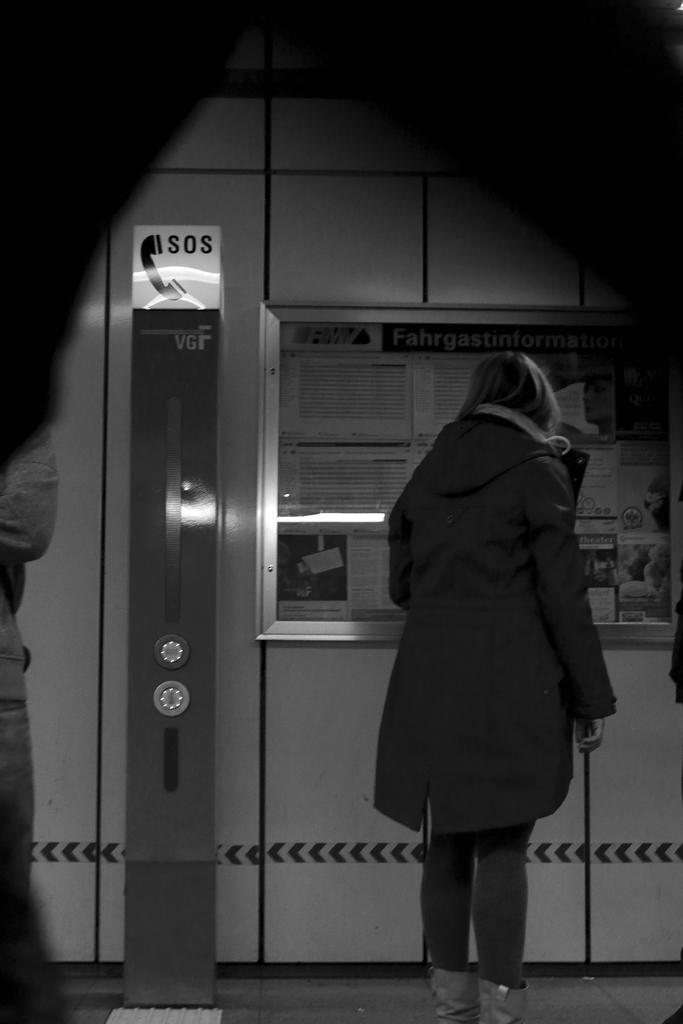<image>
Summarize the visual content of the image. a person is standing next to a sign that says sos on it 